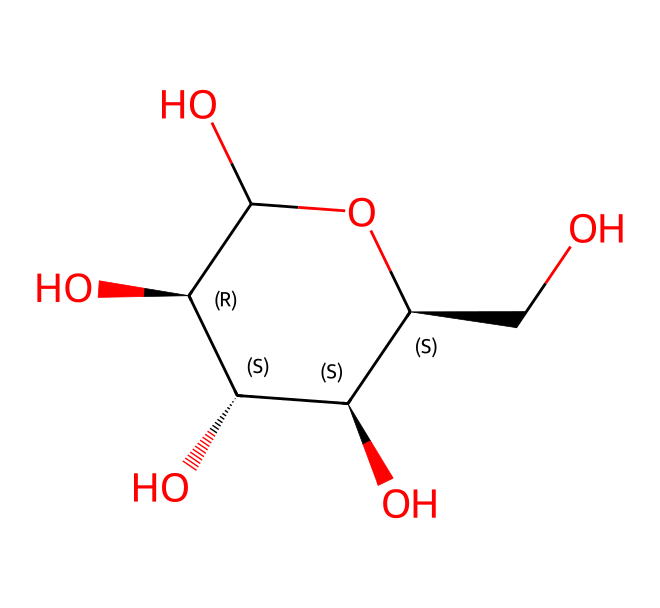How many carbon atoms are in this structure? By analyzing the SMILES representation, we can count the number of carbon (C) atoms depicted. The message shows multiple carbon atoms interlinked, including those at the beginning of the structure and within the cyclic structure. In total, there are 6 carbon atoms.
Answer: 6 What is the molecular formula of this compound? To determine the molecular formula, we calculate the number of each type of atom identified from the SMILES: 6 carbon (C), 12 hydrogen (H), and 6 oxygen (O) atoms. This data gives us the formula C6H12O6.
Answer: C6H12O6 What type of carbohydrate is represented by this structure? This structure depicts a specific arrangement of carbon, hydrogen, and oxygen, typical of glucose. As glucose is a monosaccharide, the type of carbohydrate represented is a monosaccharide.
Answer: monosaccharide How many hydroxyl (–OH) groups are present? Upon examining the structure, each –OH group (hydroxyl) can be identified along the carbon chain. Here, there are a total of 5 hydroxyl groups.
Answer: 5 What is the significance of cellulose in athletic clothing? Cellulose, as a polysaccharide made from glucose, is often used in athletic clothing due to its breathability and moisture-wicking abilities. It allows for better comfort and movement during activities.
Answer: breathability Is this structure branched or unbranched? The structure as interpreted from the SMILES string displays a straight-chain formation without any branches in its skeletal description, indicating that this is an unbranched structure.
Answer: unbranched 